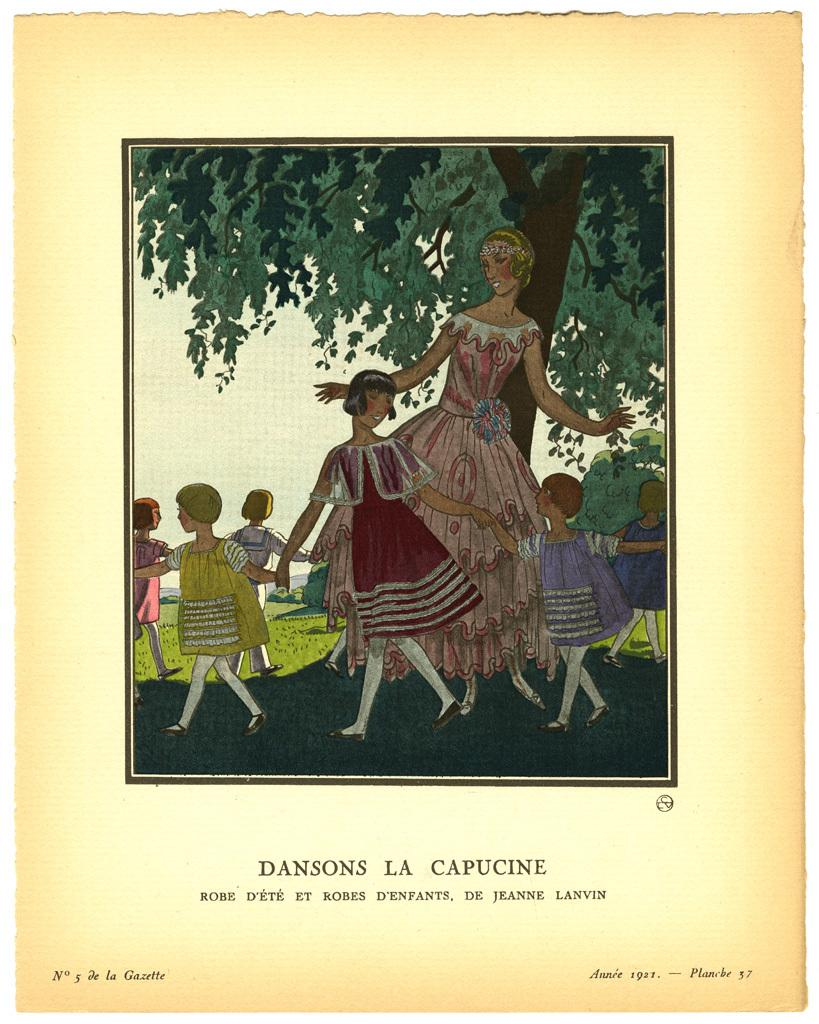What is featured on the poster in the image? There is a poster with text in the image. What activity is being depicted in the image? There are images of people playing in the image. Where are the people playing in the image? The people are playing under a tree. What type of pickle can be seen hanging from the tree in the image? There is no pickle present in the image; the people are playing under a tree. What season is depicted in the image, considering the presence of snow? There is no snow present in the image, so it cannot be determined that the image depicts winter. 